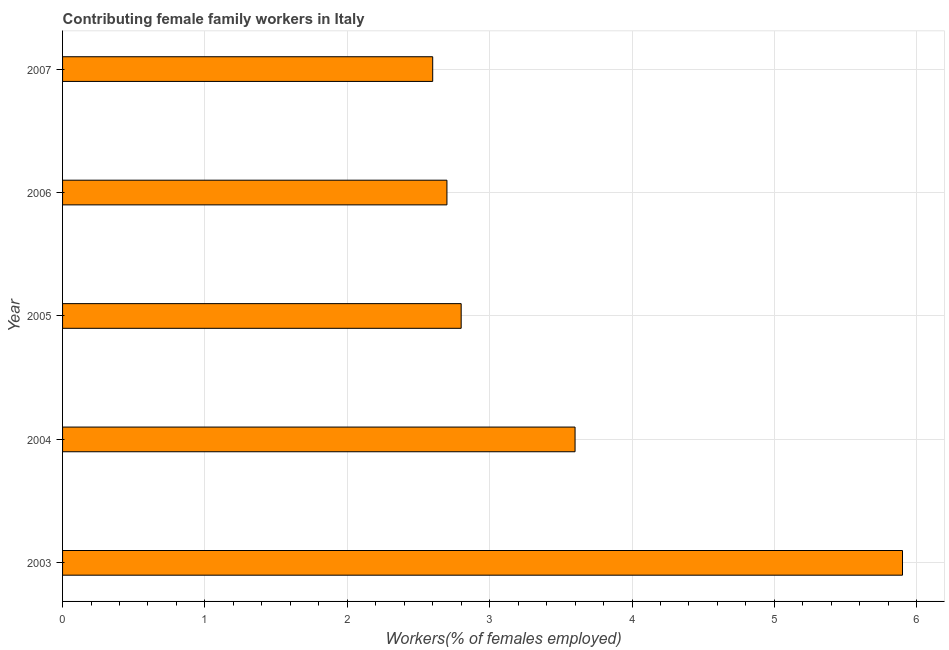Does the graph contain any zero values?
Provide a short and direct response. No. Does the graph contain grids?
Ensure brevity in your answer.  Yes. What is the title of the graph?
Give a very brief answer. Contributing female family workers in Italy. What is the label or title of the X-axis?
Offer a terse response. Workers(% of females employed). What is the label or title of the Y-axis?
Make the answer very short. Year. What is the contributing female family workers in 2007?
Make the answer very short. 2.6. Across all years, what is the maximum contributing female family workers?
Your response must be concise. 5.9. Across all years, what is the minimum contributing female family workers?
Your answer should be very brief. 2.6. In which year was the contributing female family workers maximum?
Your answer should be very brief. 2003. In which year was the contributing female family workers minimum?
Make the answer very short. 2007. What is the sum of the contributing female family workers?
Make the answer very short. 17.6. What is the difference between the contributing female family workers in 2003 and 2005?
Your response must be concise. 3.1. What is the average contributing female family workers per year?
Offer a terse response. 3.52. What is the median contributing female family workers?
Provide a succinct answer. 2.8. What is the ratio of the contributing female family workers in 2004 to that in 2005?
Ensure brevity in your answer.  1.29. Is the sum of the contributing female family workers in 2004 and 2006 greater than the maximum contributing female family workers across all years?
Make the answer very short. Yes. In how many years, is the contributing female family workers greater than the average contributing female family workers taken over all years?
Your answer should be compact. 2. What is the difference between two consecutive major ticks on the X-axis?
Give a very brief answer. 1. What is the Workers(% of females employed) in 2003?
Offer a terse response. 5.9. What is the Workers(% of females employed) of 2004?
Keep it short and to the point. 3.6. What is the Workers(% of females employed) of 2005?
Provide a short and direct response. 2.8. What is the Workers(% of females employed) in 2006?
Offer a very short reply. 2.7. What is the Workers(% of females employed) in 2007?
Your answer should be very brief. 2.6. What is the difference between the Workers(% of females employed) in 2003 and 2004?
Your answer should be compact. 2.3. What is the difference between the Workers(% of females employed) in 2003 and 2005?
Keep it short and to the point. 3.1. What is the difference between the Workers(% of females employed) in 2003 and 2006?
Your response must be concise. 3.2. What is the difference between the Workers(% of females employed) in 2004 and 2006?
Offer a very short reply. 0.9. What is the difference between the Workers(% of females employed) in 2006 and 2007?
Offer a very short reply. 0.1. What is the ratio of the Workers(% of females employed) in 2003 to that in 2004?
Make the answer very short. 1.64. What is the ratio of the Workers(% of females employed) in 2003 to that in 2005?
Offer a terse response. 2.11. What is the ratio of the Workers(% of females employed) in 2003 to that in 2006?
Offer a very short reply. 2.19. What is the ratio of the Workers(% of females employed) in 2003 to that in 2007?
Give a very brief answer. 2.27. What is the ratio of the Workers(% of females employed) in 2004 to that in 2005?
Your answer should be very brief. 1.29. What is the ratio of the Workers(% of females employed) in 2004 to that in 2006?
Give a very brief answer. 1.33. What is the ratio of the Workers(% of females employed) in 2004 to that in 2007?
Make the answer very short. 1.39. What is the ratio of the Workers(% of females employed) in 2005 to that in 2006?
Your answer should be compact. 1.04. What is the ratio of the Workers(% of females employed) in 2005 to that in 2007?
Offer a very short reply. 1.08. What is the ratio of the Workers(% of females employed) in 2006 to that in 2007?
Offer a terse response. 1.04. 